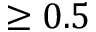<formula> <loc_0><loc_0><loc_500><loc_500>\geq 0 . 5</formula> 